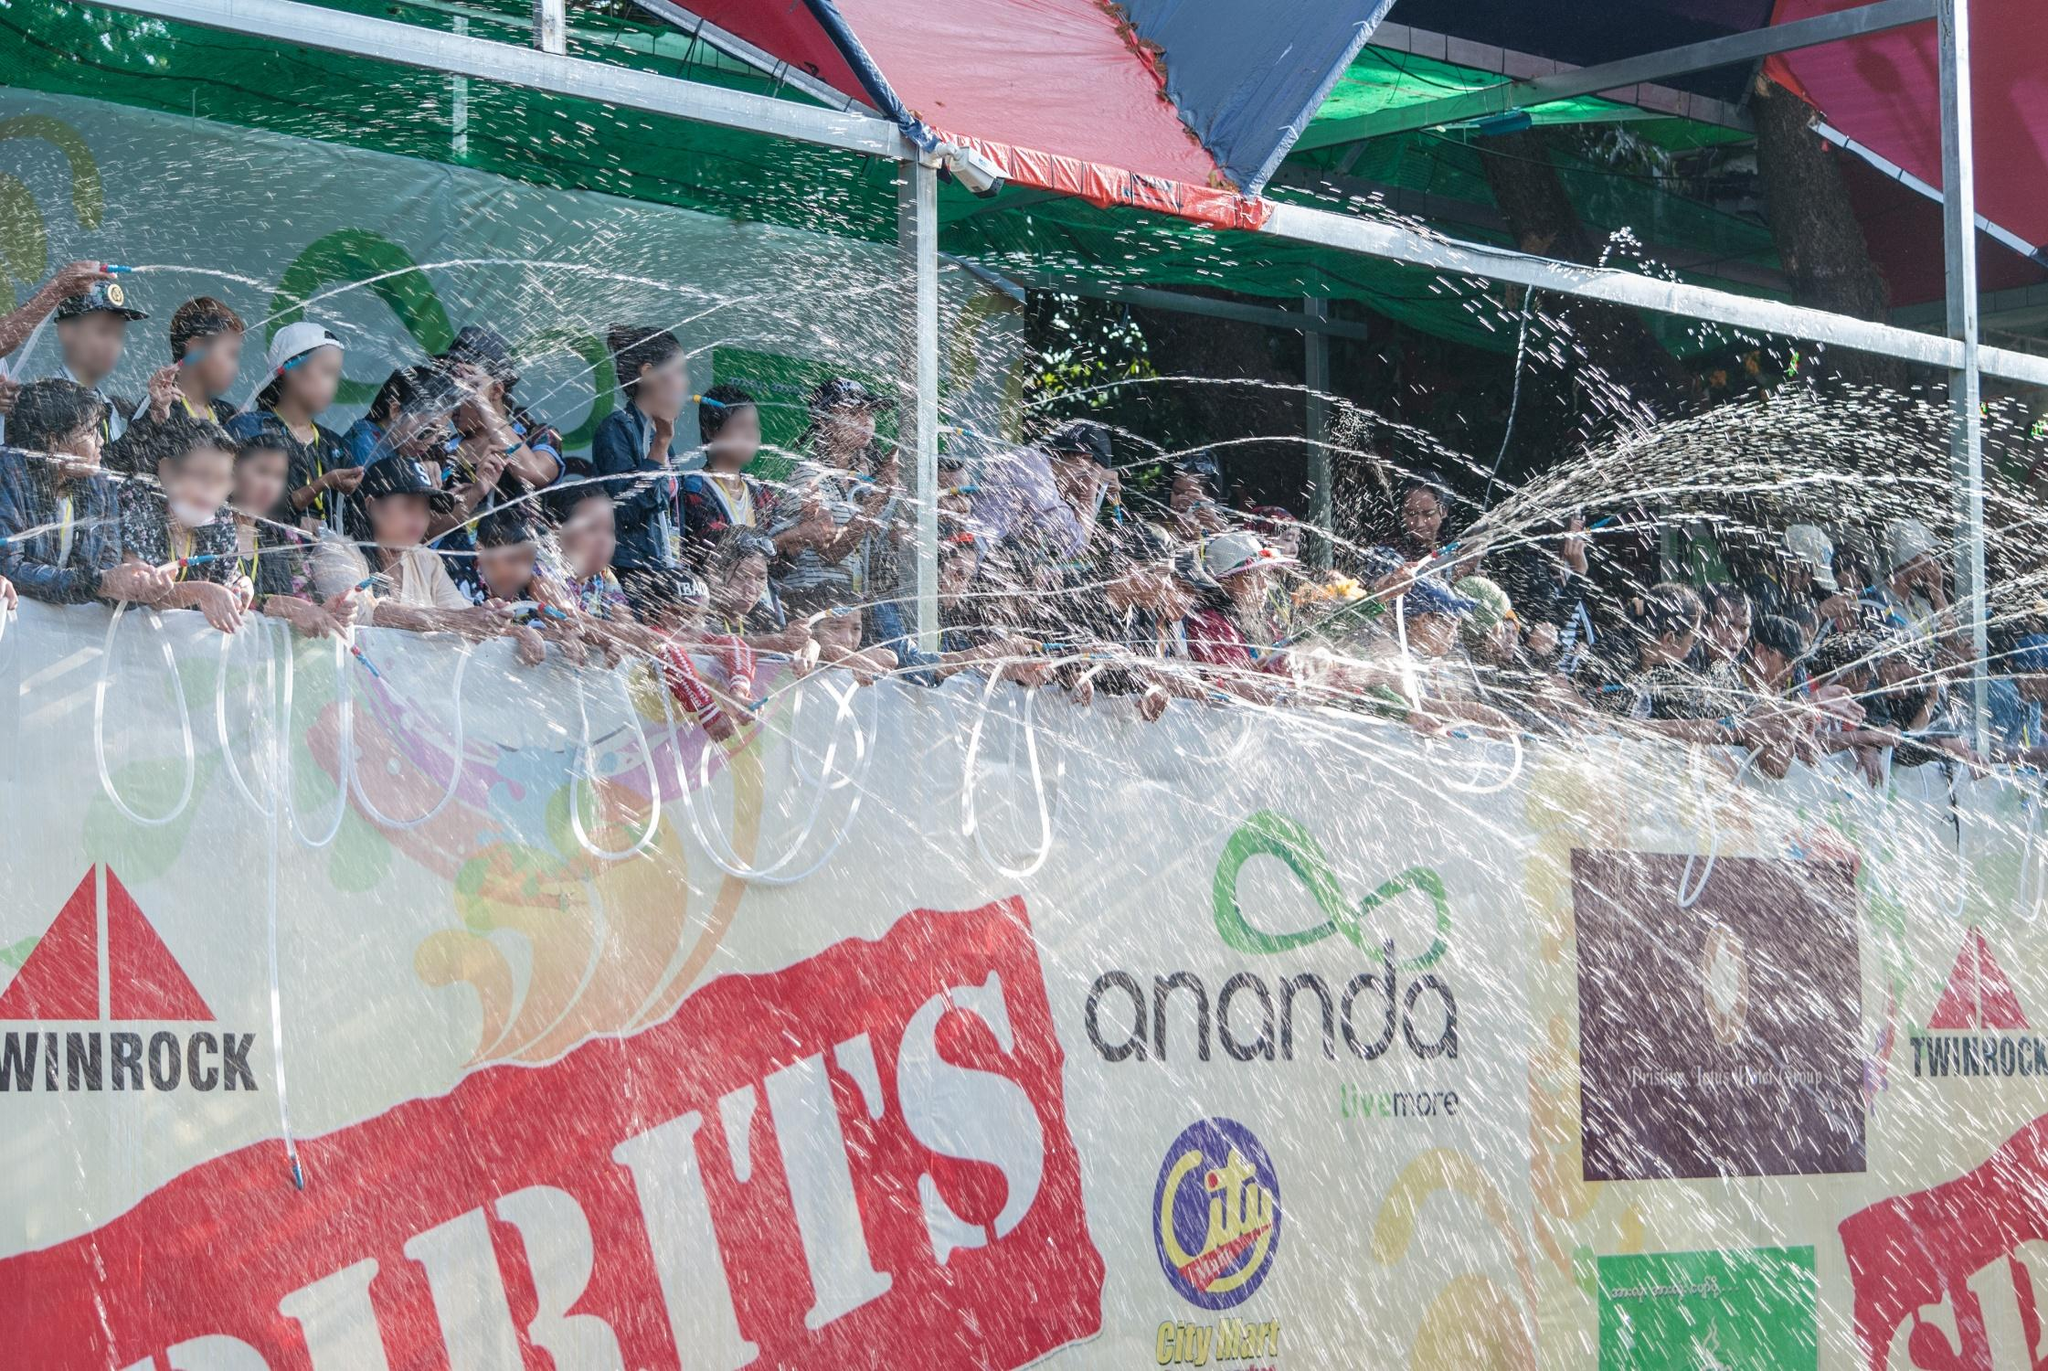Why might someone participate in this water fight? Participating in this water fight offers a chance to engage in a joyful, communal activity that brings people together. It’s an opportunity to celebrate with friends and family, to partake in cultural traditions, and to experience a sense of connection and shared happiness. For many, it represents a break from the daily grind, a moment to let loose and revel in the joy of the present. Additionally, in many cultures, such as during the Songkran festival, water fights symbolize purification and the washing away of past misfortunes, thus welcoming a fresh start and new beginnings. The sheer fun and exhilaration of being part of such a vibrant, energetic event where everyone is laughing, playing, and enjoying themselves are reasons enough to join in. It’s about creating memories and cherishing the unity and spirit of the community. 